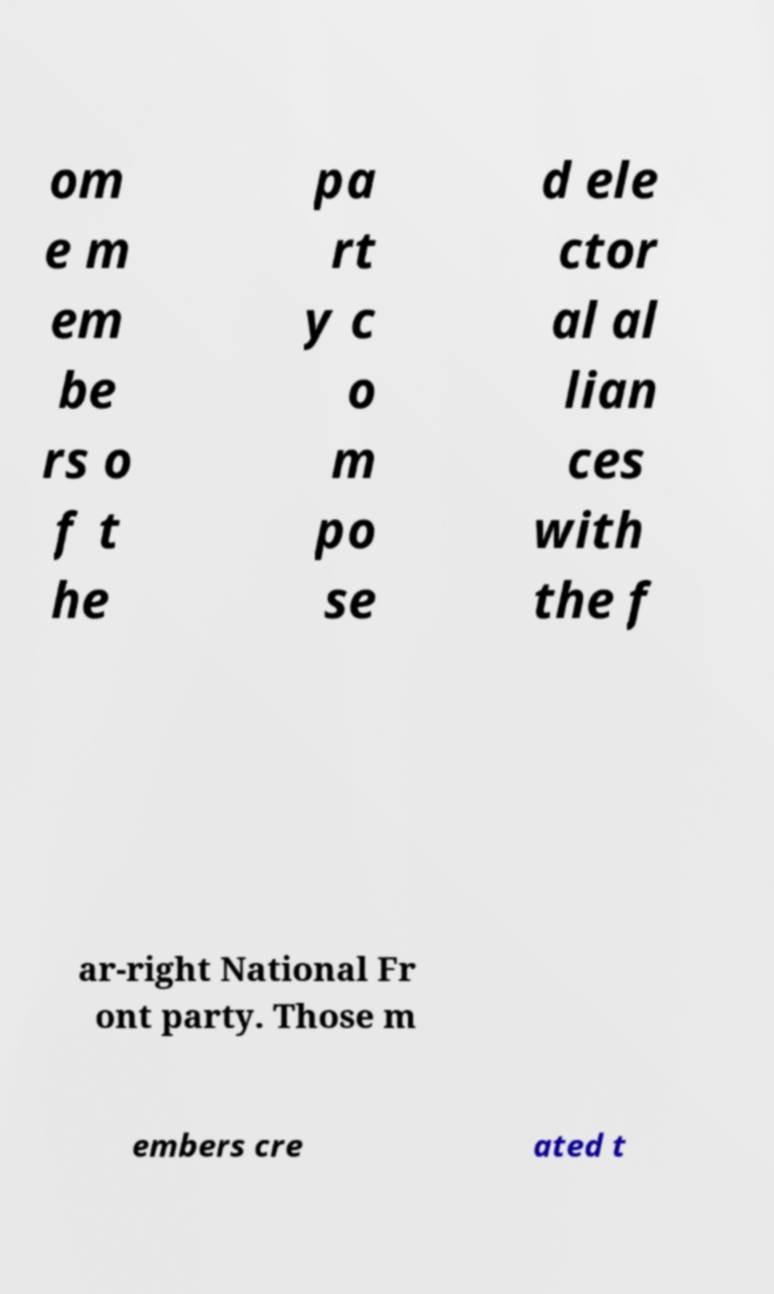Please identify and transcribe the text found in this image. om e m em be rs o f t he pa rt y c o m po se d ele ctor al al lian ces with the f ar-right National Fr ont party. Those m embers cre ated t 